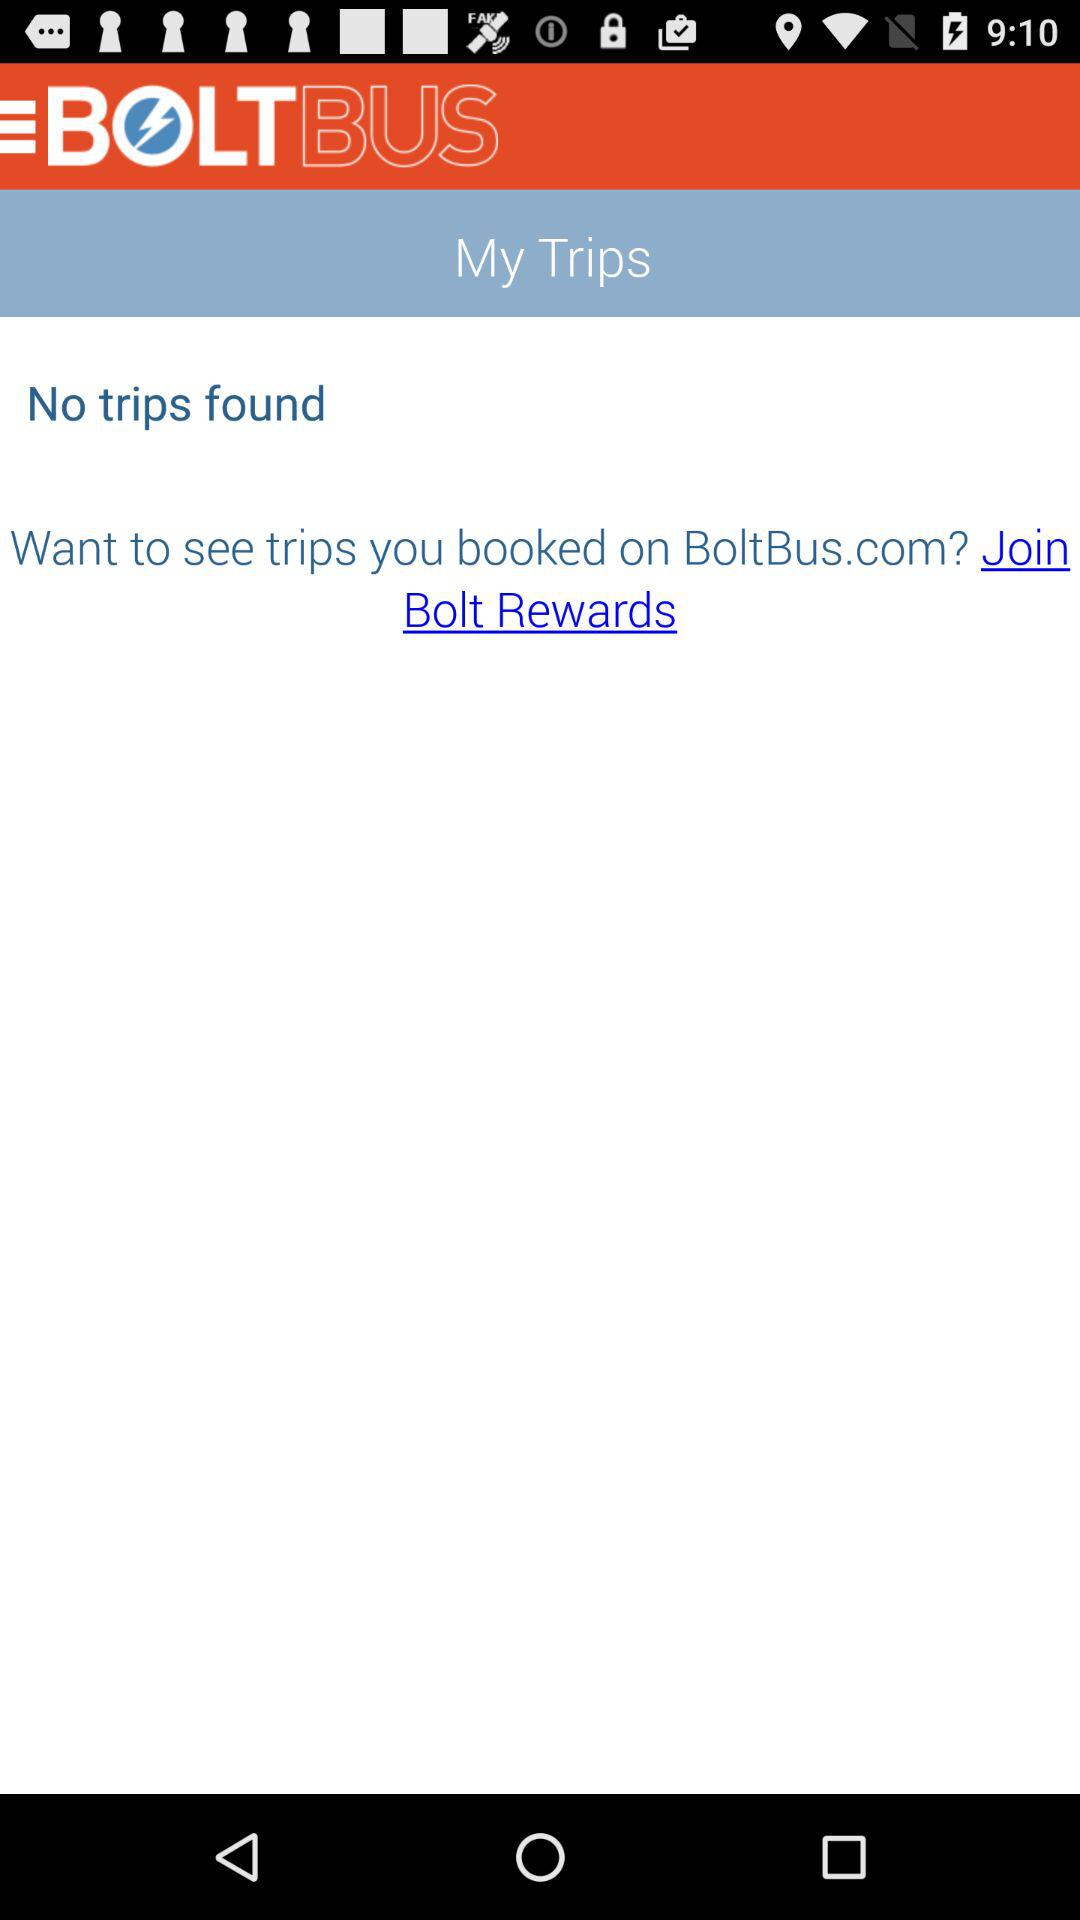What is the app name? The app name is "BOLTBUS". 